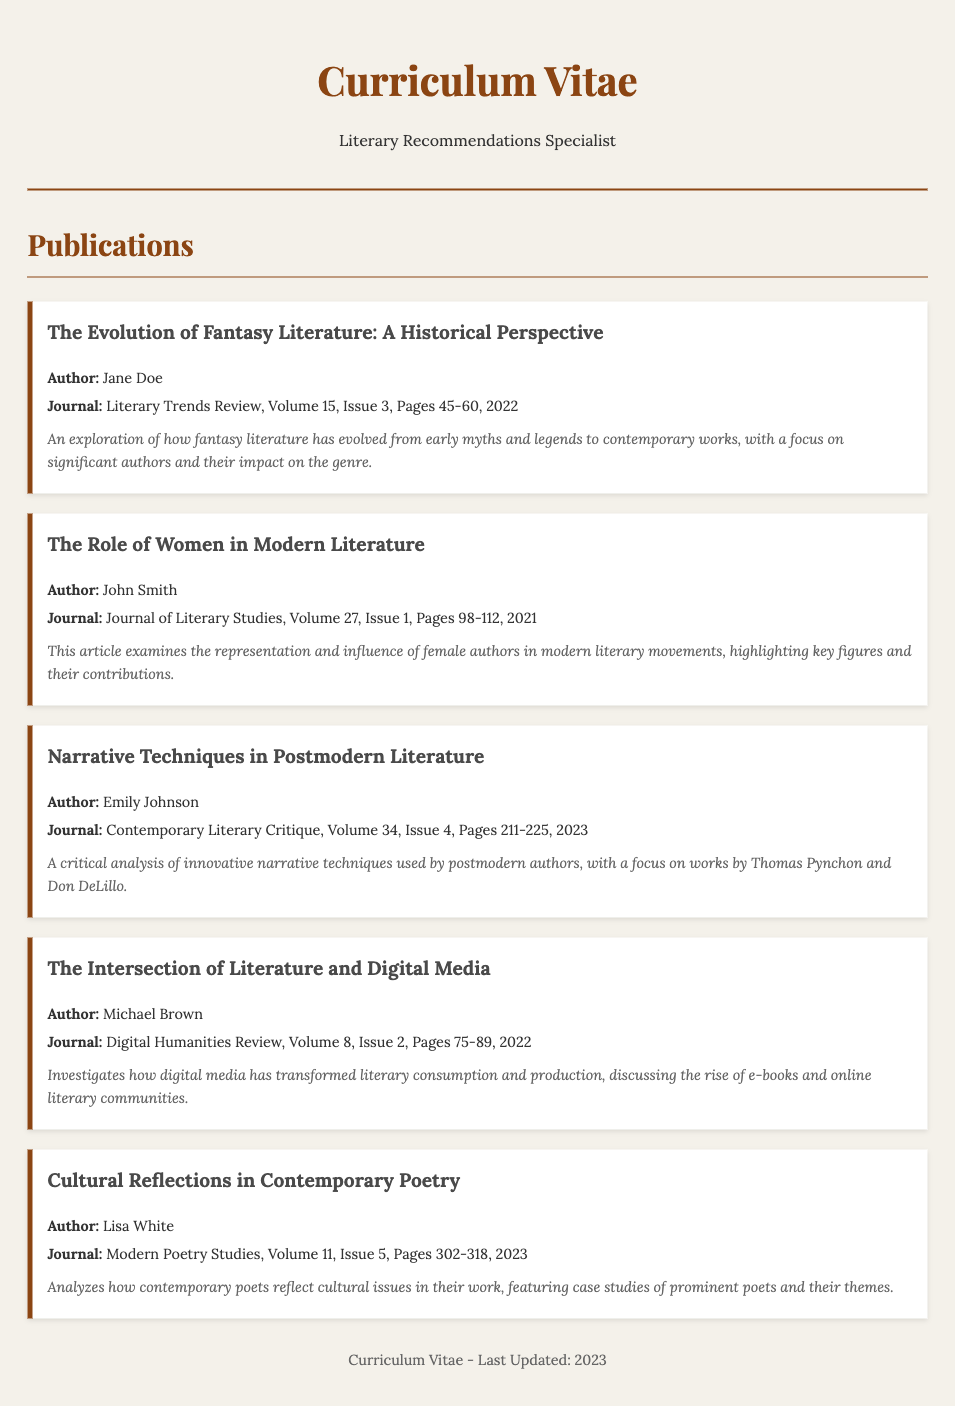What is the title of the article by Jane Doe? The title is listed directly under the author's name in the publication section.
Answer: The Evolution of Fantasy Literature: A Historical Perspective How many articles did John Smith publish? Counting the publications, John Smith appears only once in the document.
Answer: 1 What is the publication year of the article "Narrative Techniques in Postmodern Literature"? The publication date is found within the journal citation for that article, specifically in the last section.
Answer: 2023 Which journal published the article "Cultural Reflections in Contemporary Poetry"? The journal name is included after the author's name in the publication details.
Answer: Modern Poetry Studies Who authored the article on digital media? The author is specified right before the journal information in the respective publication section.
Answer: Michael Brown What is a key theme discussed in "The Role of Women in Modern Literature"? The theme is provided in the article description that follows the publication details.
Answer: Representation and influence of female authors How many pages does "The Intersection of Literature and Digital Media" span? The page range is included in the journal citation for that publication.
Answer: 75-89 Which volume of the "Literary Trends Review" features Jane Doe's article? The volume number can be found in the citation for the respective publication.
Answer: Volume 15 What type of literature is the focus of the article written by Emily Johnson? The article focus is indicated in the title of the publication.
Answer: Postmodern Literature 